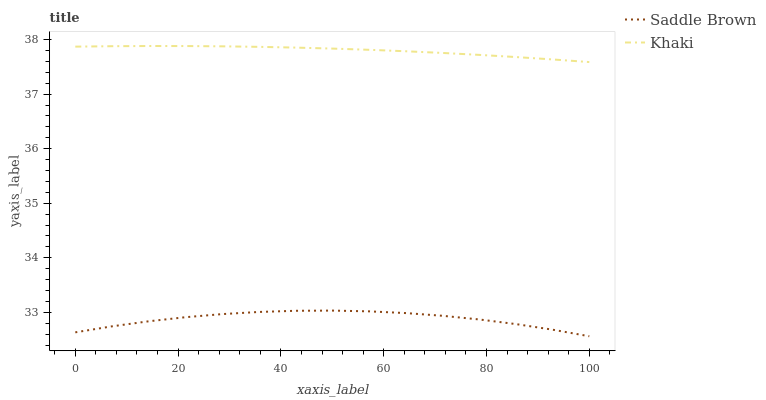Does Saddle Brown have the minimum area under the curve?
Answer yes or no. Yes. Does Khaki have the maximum area under the curve?
Answer yes or no. Yes. Does Saddle Brown have the maximum area under the curve?
Answer yes or no. No. Is Khaki the smoothest?
Answer yes or no. Yes. Is Saddle Brown the roughest?
Answer yes or no. Yes. Is Saddle Brown the smoothest?
Answer yes or no. No. Does Saddle Brown have the lowest value?
Answer yes or no. Yes. Does Khaki have the highest value?
Answer yes or no. Yes. Does Saddle Brown have the highest value?
Answer yes or no. No. Is Saddle Brown less than Khaki?
Answer yes or no. Yes. Is Khaki greater than Saddle Brown?
Answer yes or no. Yes. Does Saddle Brown intersect Khaki?
Answer yes or no. No. 